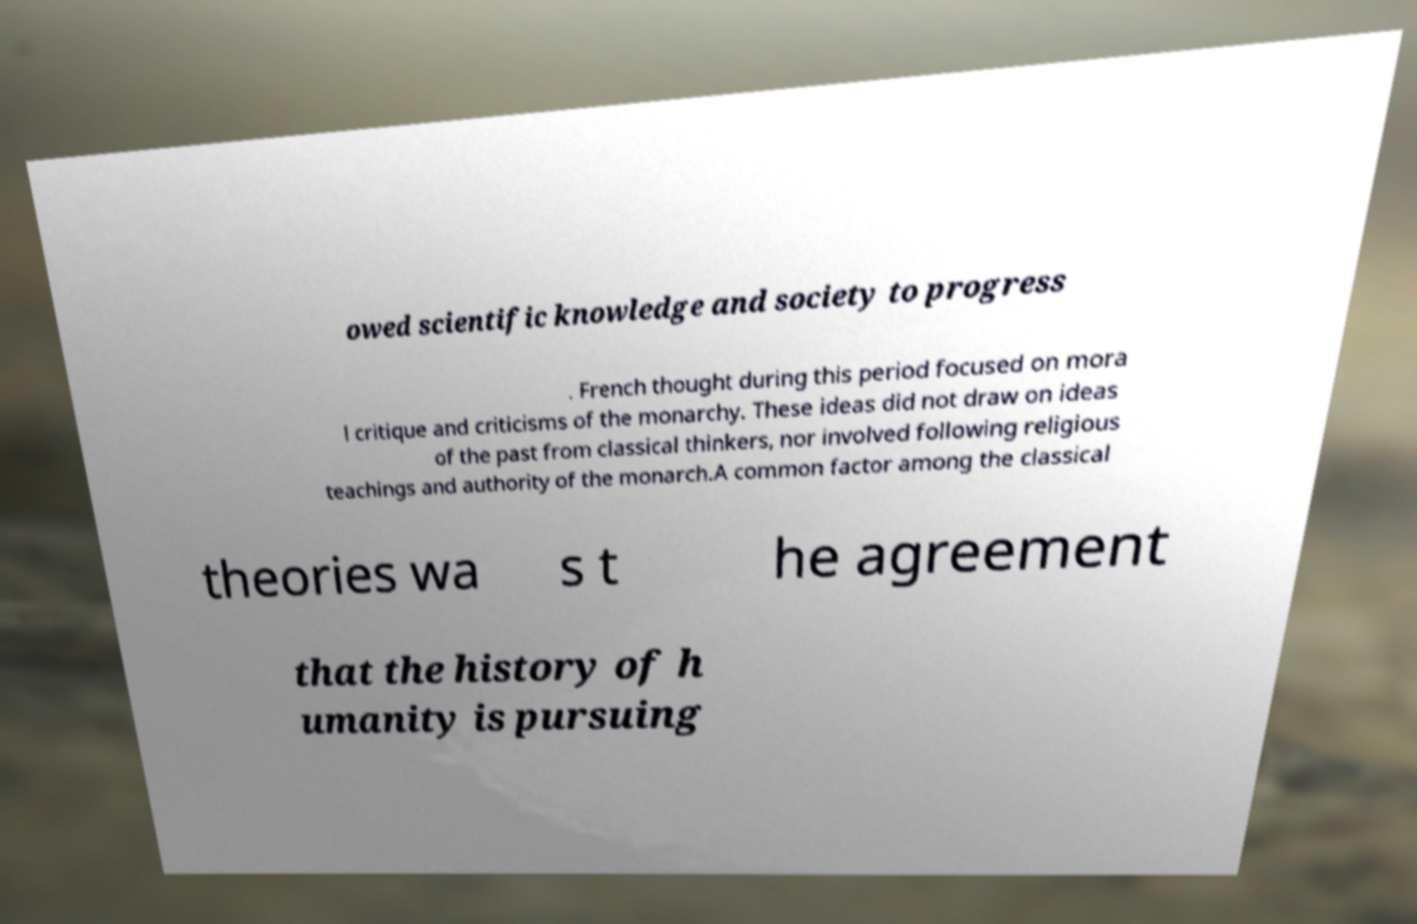Could you extract and type out the text from this image? owed scientific knowledge and society to progress . French thought during this period focused on mora l critique and criticisms of the monarchy. These ideas did not draw on ideas of the past from classical thinkers, nor involved following religious teachings and authority of the monarch.A common factor among the classical theories wa s t he agreement that the history of h umanity is pursuing 